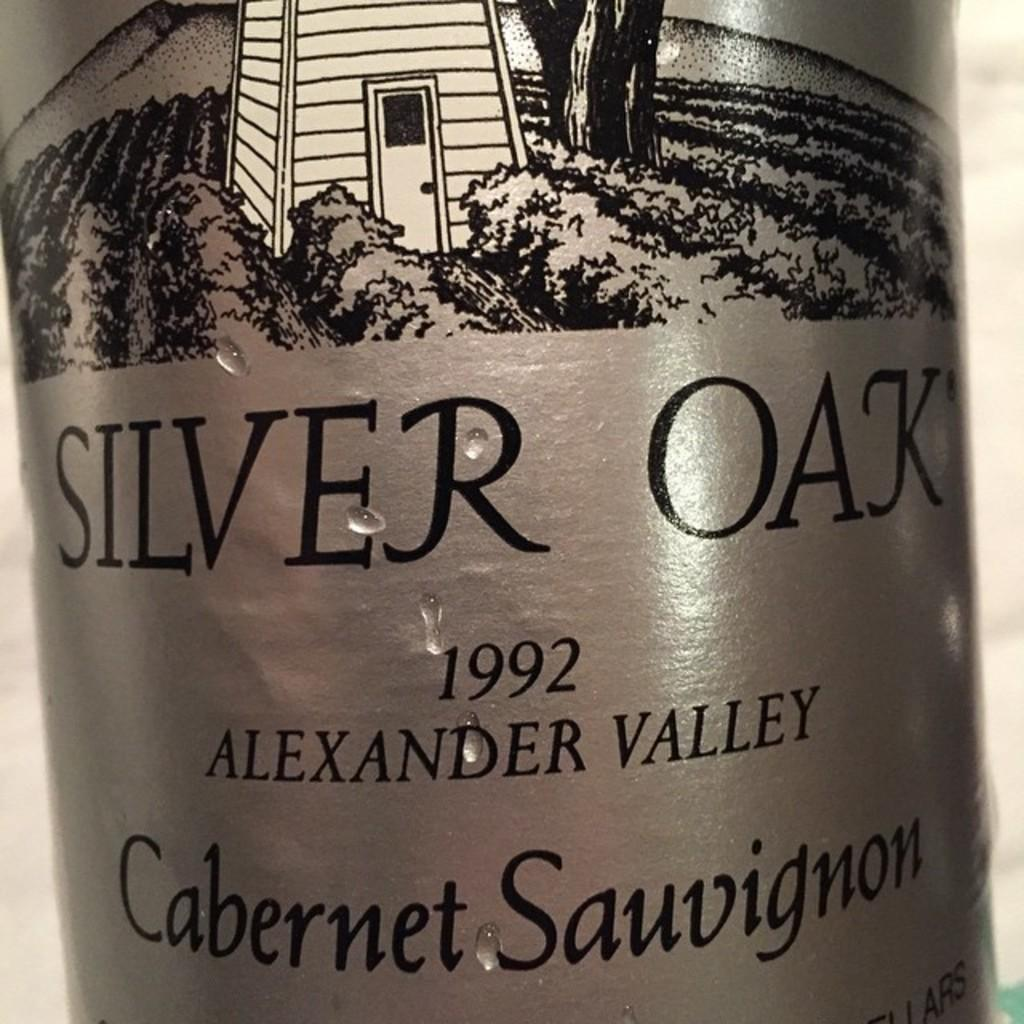<image>
Offer a succinct explanation of the picture presented. the word silver is on a bottle of drink 